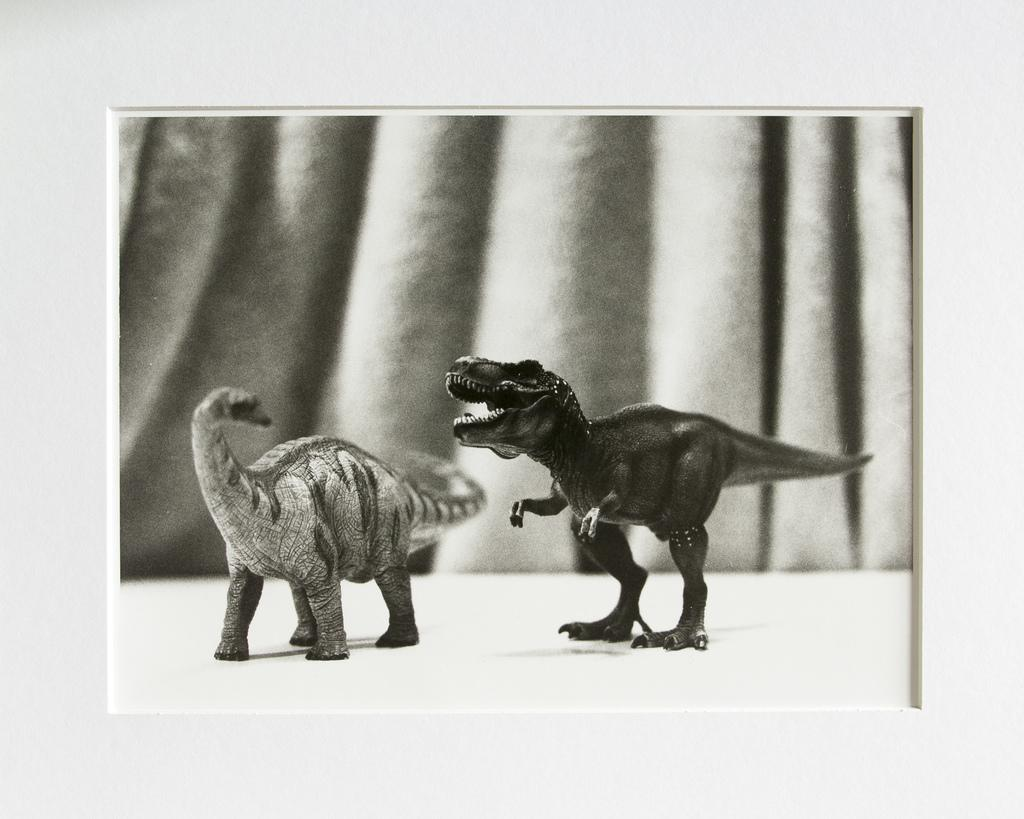What objects can be seen in the front of the image? There are two toys in the front of the image. What can be seen in the background of the image? There is a curtain in the background of the image. How would you describe the appearance of the background? The background appears blurry. What is the overall appearance of the image? The image has the appearance of a photo frame. What type of seed is being polished in the image? There is no seed or polishing activity present in the image. 